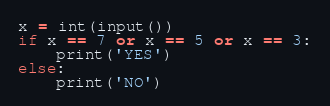Convert code to text. <code><loc_0><loc_0><loc_500><loc_500><_Python_>x = int(input())
if x == 7 or x == 5 or x == 3:
    print('YES')
else:
    print('NO')</code> 